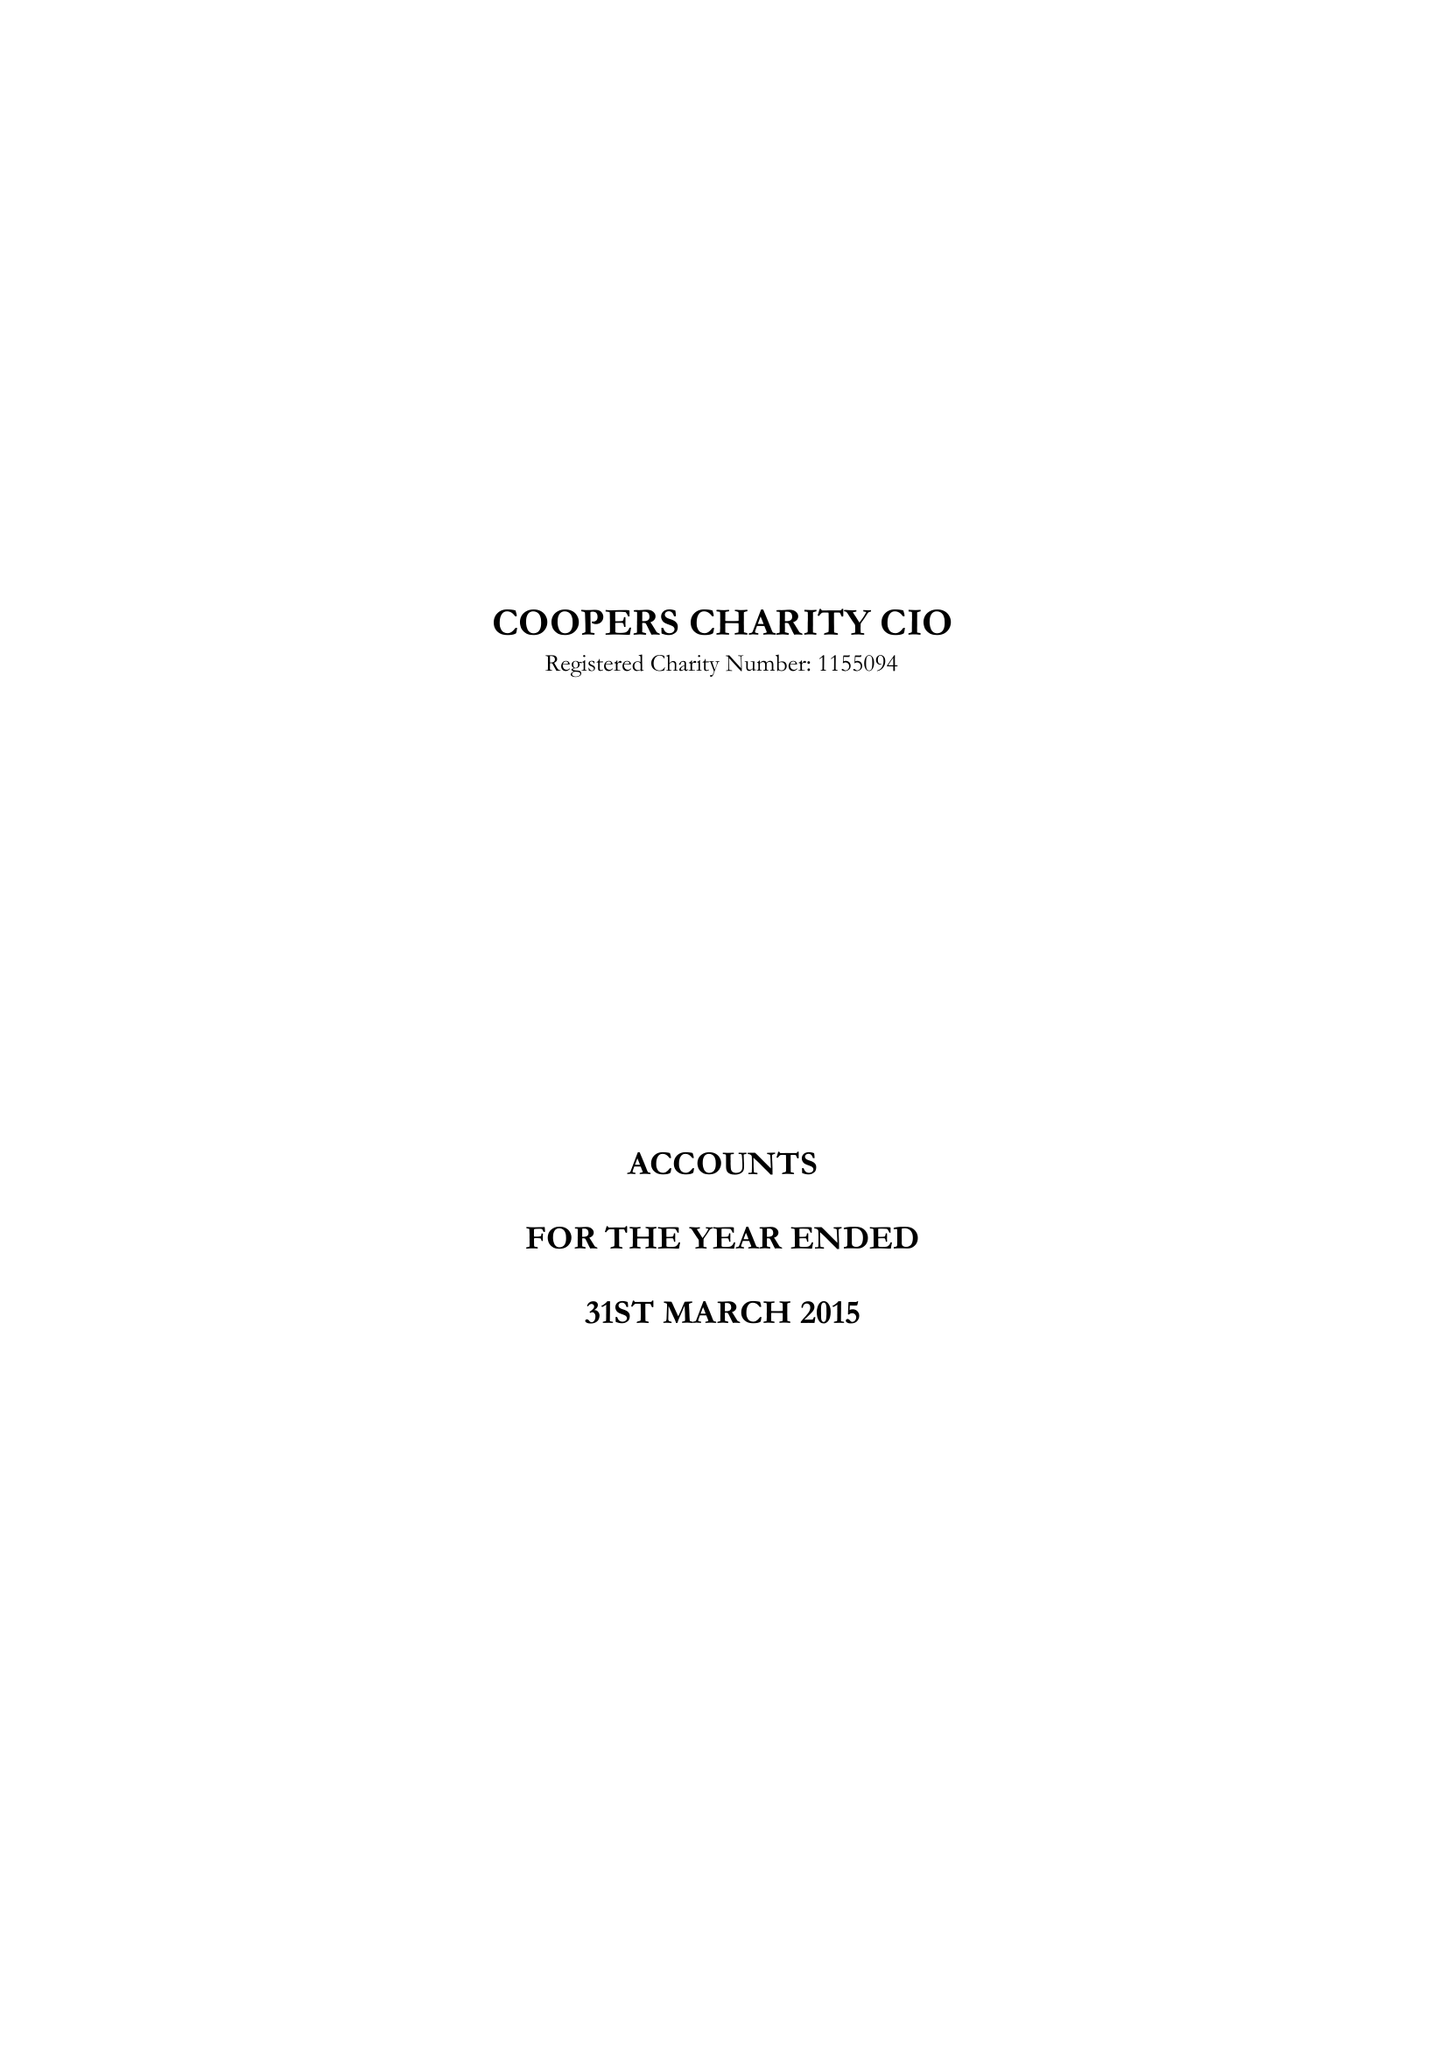What is the value for the address__postcode?
Answer the question using a single word or phrase. EC2M 4TH 